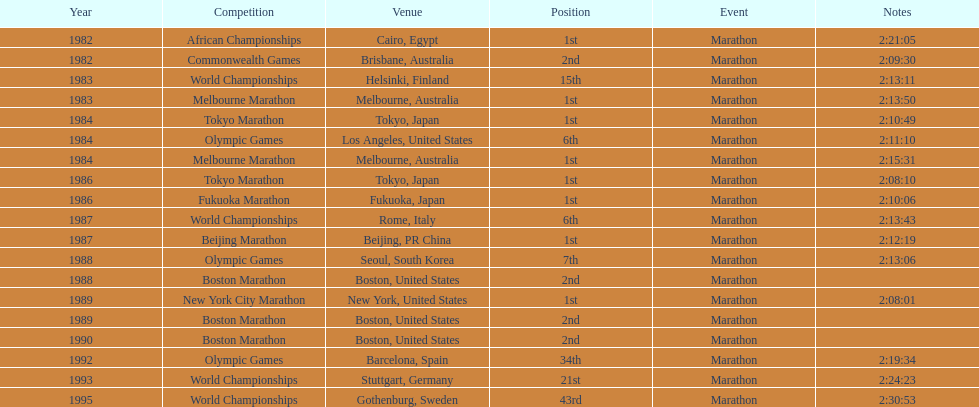In what year was the runner involved in the maximum marathons? 1984. 